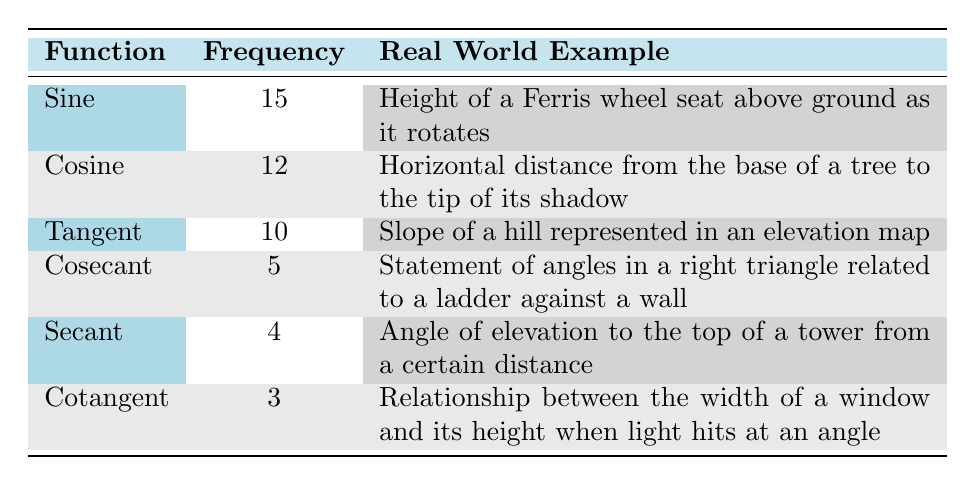What is the frequency of the Sine function? The table clearly lists the frequency of each trigonometric function. For the Sine function, the frequency is directly specified in the second column as 15.
Answer: 15 Which trigonometric function has the least frequency? By examining the frequencies listed in the table, we can identify that Cotangent has the least frequency, recorded as 3 in the frequency column.
Answer: Cotangent What is the sum of the frequencies for Tangent and Cosecant? To find this sum, we look at the frequencies of Tangent (10) and Cosecant (5). Summing these gives 10 + 5 = 15.
Answer: 15 Is the frequency of the Cosine function greater than that of the Secant function? Comparing the two frequencies in the table, Cosine has a frequency of 12, while Secant has a frequency of 4. Since 12 is greater than 4, the answer is yes.
Answer: Yes What is the average frequency of all the listed trigonometric functions? We first sum up the frequencies: 15 + 12 + 10 + 5 + 4 + 3 = 49. There are 6 functions, so we calculate the average by dividing the total sum by the number of functions: 49 / 6 = approximately 8.17.
Answer: Approximately 8.17 What function has a real-world example related to the height of a Ferris wheel? The table states that the Sine function's real-world example relates to the height of a Ferris wheel seat above ground as it rotates. This can be found under the real-world example column for Sine.
Answer: Sine Which function's frequency is primarily associated with the horizontal distance from the base of a tree to the tip of its shadow? According to the table, the Cosine function corresponds to this real-world situation, as indicated in the real-world example column next to Cosine.
Answer: Cosine Calculate the difference in frequency between the Sine and Cosecant functions. The frequency of Sine is 15, and for Cosecant, it is 5. The difference is calculated as 15 - 5 = 10.
Answer: 10 If we combine the frequencies of Secant and Cotangent, what is the total? The frequency of Secant is 4 and Cotangent is 3. Therefore, we add them: 4 + 3 = 7.
Answer: 7 